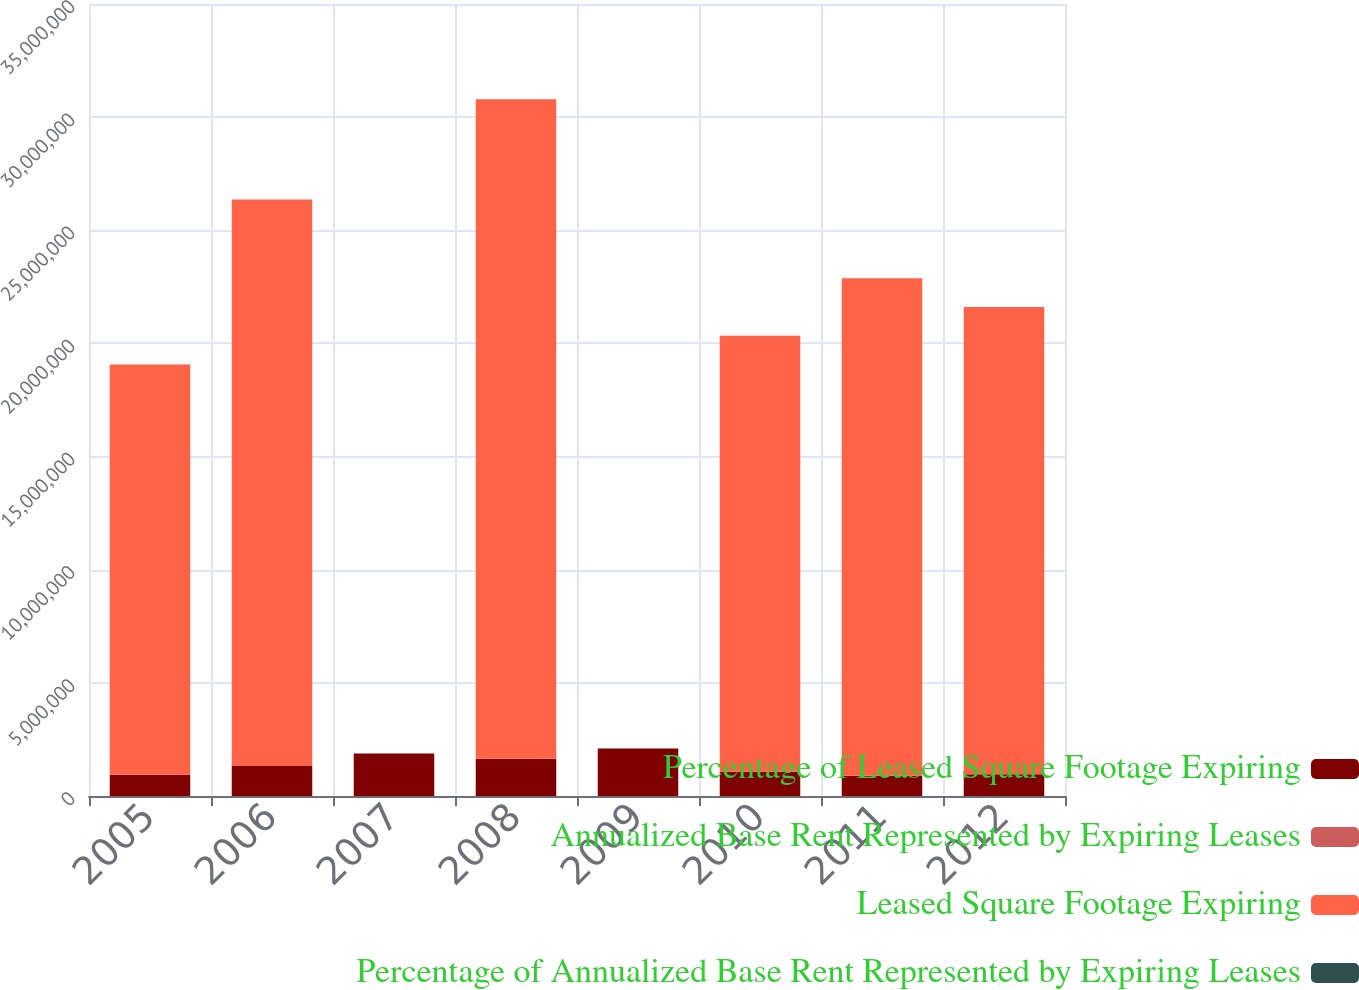Convert chart to OTSL. <chart><loc_0><loc_0><loc_500><loc_500><stacked_bar_chart><ecel><fcel>2005<fcel>2006<fcel>2007<fcel>2008<fcel>2009<fcel>2010<fcel>2011<fcel>2012<nl><fcel>Percentage of Leased Square Footage Expiring<fcel>936000<fcel>1.324e+06<fcel>1.879e+06<fcel>1.646e+06<fcel>2.096e+06<fcel>1.073e+06<fcel>892000<fcel>956000<nl><fcel>Annualized Base Rent Represented by Expiring Leases<fcel>6<fcel>8<fcel>12<fcel>10<fcel>13<fcel>7<fcel>6<fcel>6<nl><fcel>Leased Square Footage Expiring<fcel>1.8132e+07<fcel>2.5031e+07<fcel>13<fcel>2.9148e+07<fcel>13<fcel>1.9269e+07<fcel>2.1983e+07<fcel>2.0651e+07<nl><fcel>Percentage of Annualized Base Rent Represented by Expiring Leases<fcel>6<fcel>9<fcel>11<fcel>10<fcel>13<fcel>7<fcel>8<fcel>7<nl></chart> 